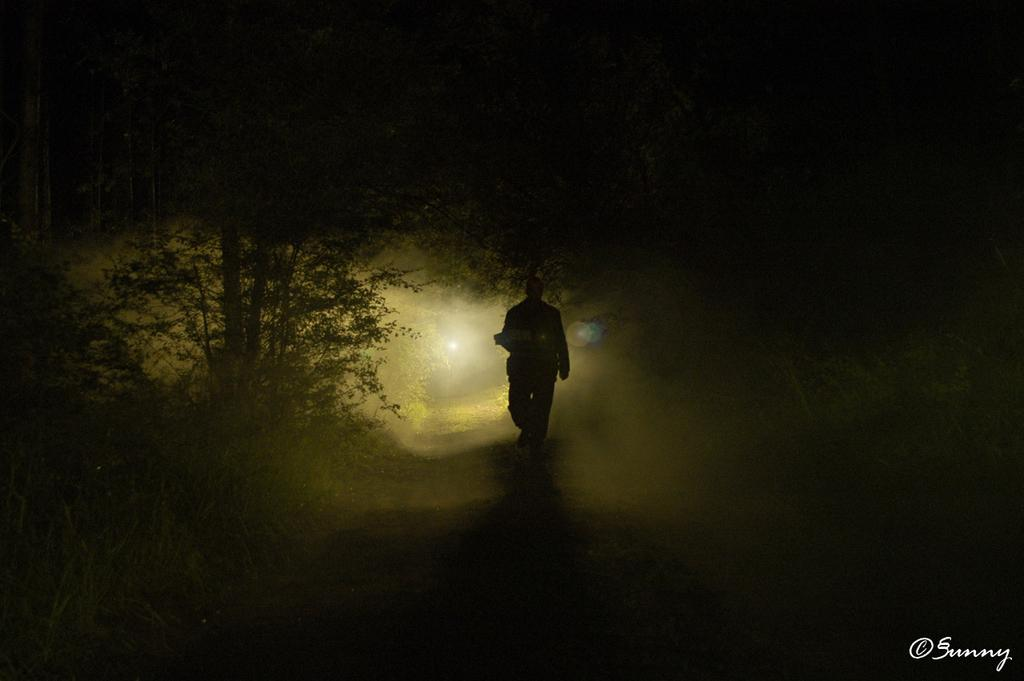What is the main subject of the image? There is a person walking in the image. Where is the person walking? The person is walking on a path. What can be seen on the left side of the image? There is a tree on the left side of the image. What type of muscle can be seen flexing in the image? There is no muscle visible in the image, as it only shows a person walking on a path with a tree on the left side. 